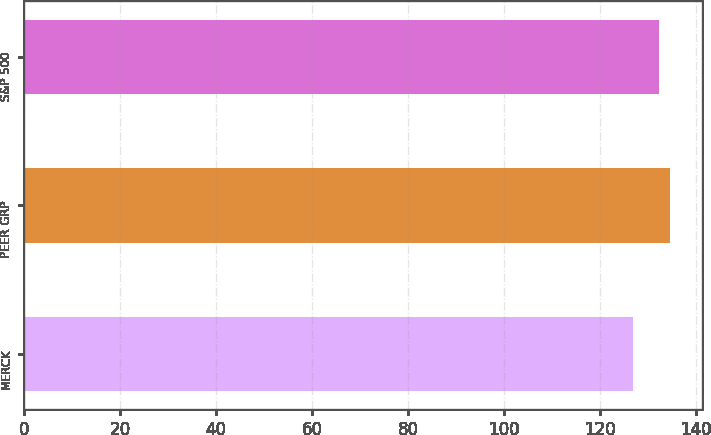Convert chart. <chart><loc_0><loc_0><loc_500><loc_500><bar_chart><fcel>MERCK<fcel>PEER GRP<fcel>S&P 500<nl><fcel>126.9<fcel>134.6<fcel>132.4<nl></chart> 